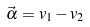Convert formula to latex. <formula><loc_0><loc_0><loc_500><loc_500>\vec { \alpha } = v _ { 1 } - v _ { 2 }</formula> 